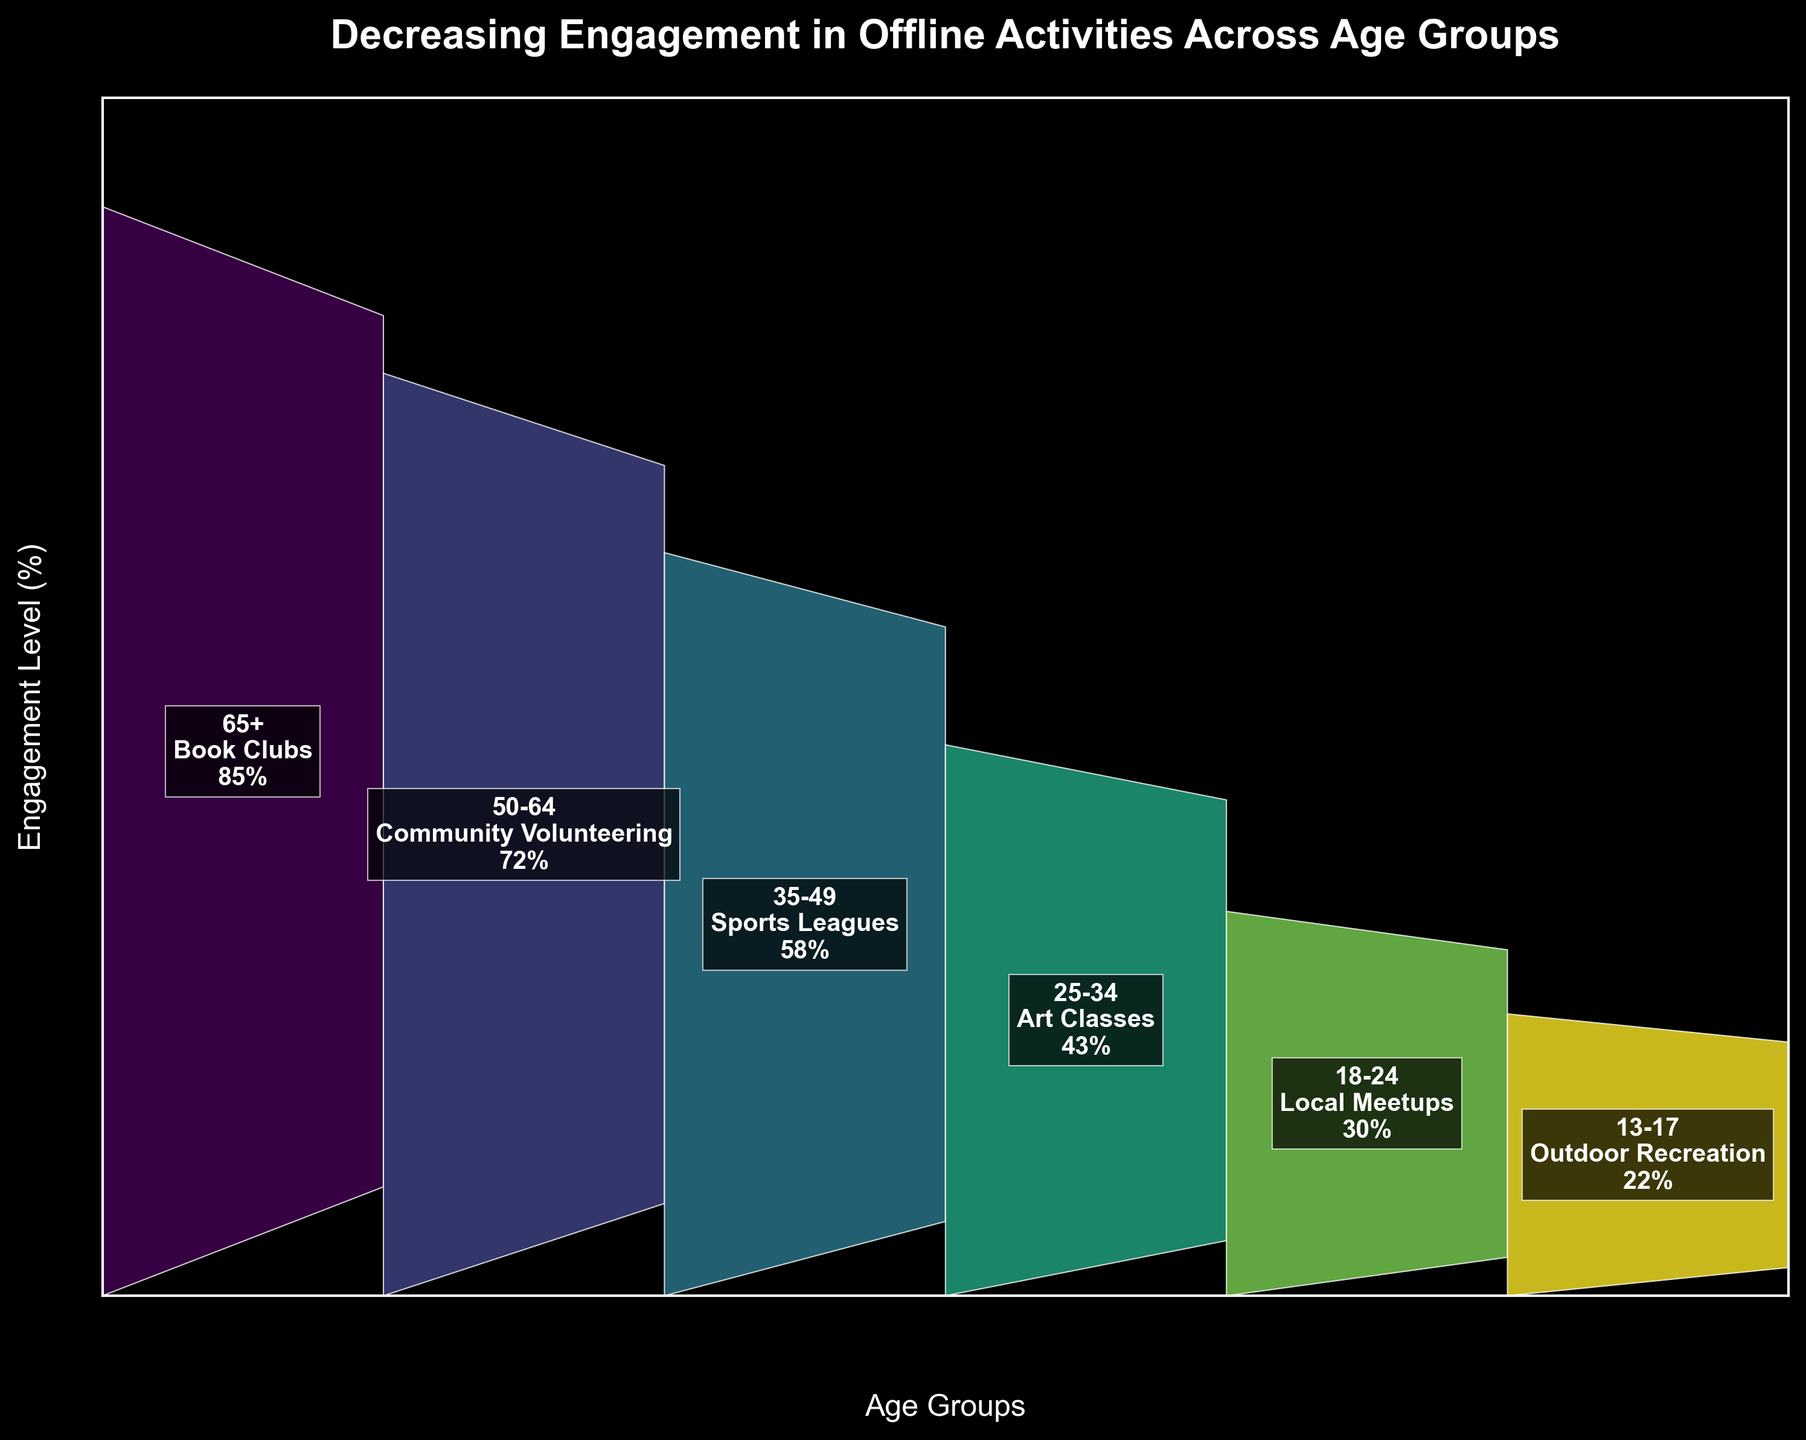What's the title of the chart? The title is written at the top of the chart.
Answer: Decreasing Engagement in Offline Activities Across Age Groups What is the engagement level of 35-49 age group? The engagement level is written inside the funnel section corresponding to the age group 35-49.
Answer: 58% Which age group has the lowest engagement level? By comparing the engagement levels indicated in each section of the funnel, we can see that the age group 13-17 has the lowest engagement level.
Answer: 13-17 How many age groups are represented in the chart? The chart has one section for each age group. Counting the sections gives the total number of age groups.
Answer: 6 Compare the engagement levels of the 50-64 and 25-34 age groups. Which is higher and by how much? The engagement levels of 50-64 and 25-34 age groups are 72% and 43%, respectively. Subtracting the latter from the former gives the difference.
Answer: The engagement level of the 50-64 age group is higher by 29% What activity corresponds to the 18-24 age group and what is its engagement level? The activity and engagement level for each age group are written within the funnel sections. For the 18-24 age group, it is Local Meetups with an engagement level of 30%.
Answer: Local Meetups, 30% Calculate the average engagement level across all age groups. Add the engagement levels of all age groups and divide by the number of age groups to find the average. (85 + 72 + 58 + 43 + 30 + 22) / 6 = 51.67%
Answer: 51.67% Which age group has the highest engagement level and what activity is it associated with? The funnel section with the highest engagement level corresponds to the 65+ age group and the activity is Book Clubs.
Answer: 65+, Book Clubs 